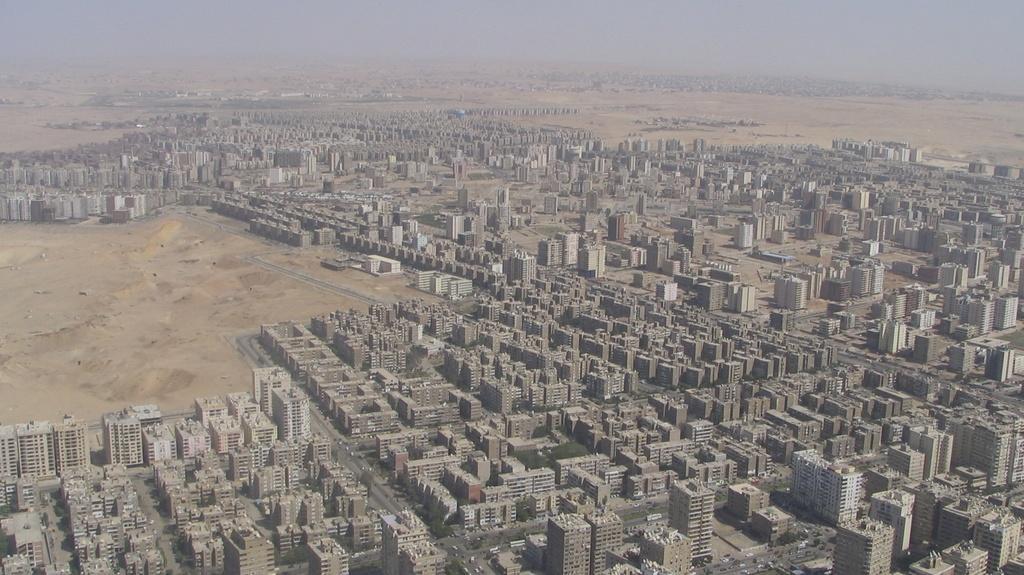Describe this image in one or two sentences. This picture shows top view. We see buildings and a cloudy sky. 